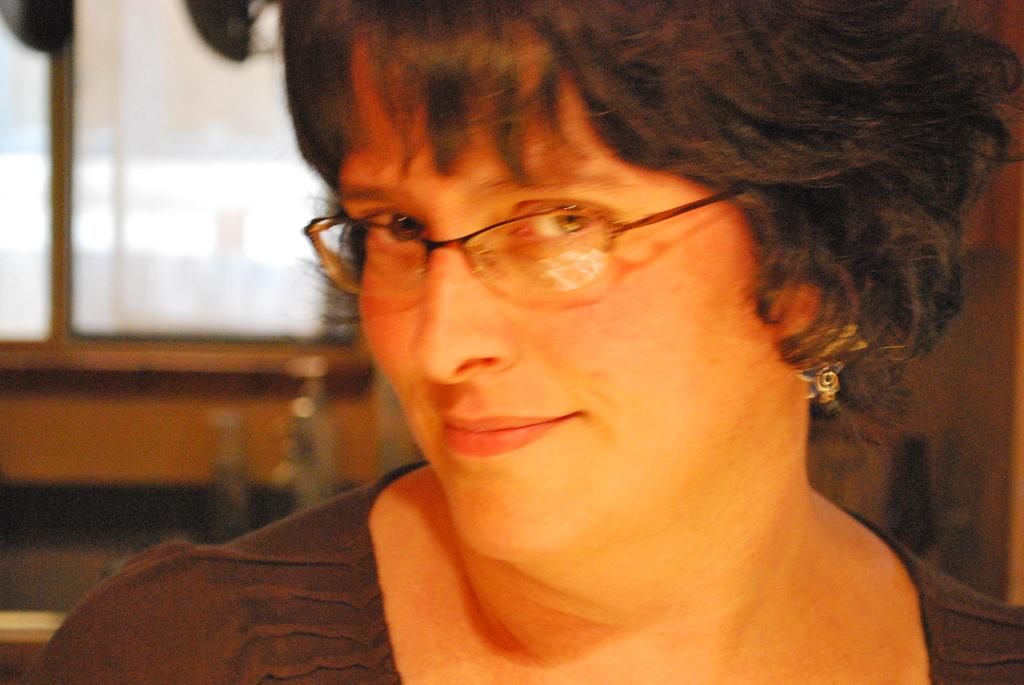Who is the main subject in the image? There is a woman in the picture. What is the woman wearing in the image? The woman is wearing spectacles. Are there any accessories visible on the woman? Yes, the woman has an earring in her ear. What can be seen in the background of the image? There are other objects in the background of the image. What type of creature is the woman exchanging with in the image? There is no creature present in the image, nor is there any indication of an exchange taking place. 